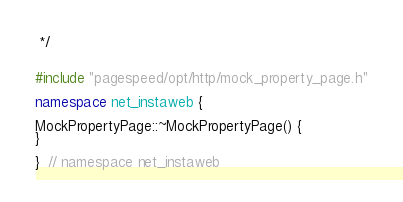<code> <loc_0><loc_0><loc_500><loc_500><_C++_> */


#include "pagespeed/opt/http/mock_property_page.h"

namespace net_instaweb {

MockPropertyPage::~MockPropertyPage() {
}

}  // namespace net_instaweb
</code> 